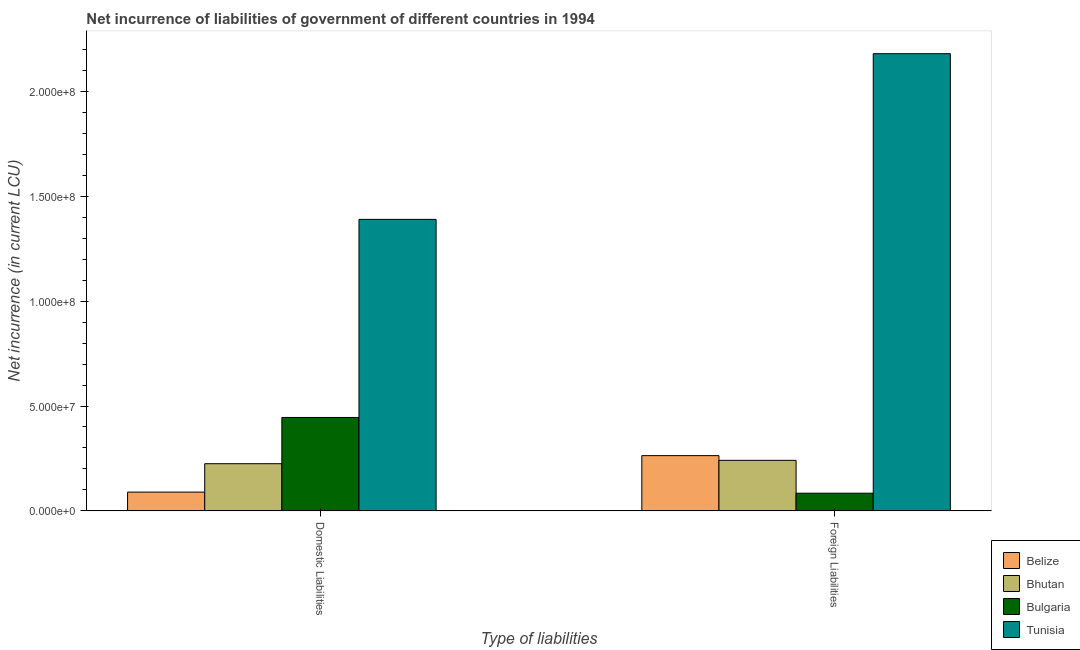How many different coloured bars are there?
Your answer should be very brief. 4. How many bars are there on the 2nd tick from the left?
Your answer should be very brief. 4. What is the label of the 1st group of bars from the left?
Offer a very short reply. Domestic Liabilities. What is the net incurrence of domestic liabilities in Belize?
Provide a succinct answer. 8.96e+06. Across all countries, what is the maximum net incurrence of foreign liabilities?
Your answer should be very brief. 2.18e+08. Across all countries, what is the minimum net incurrence of domestic liabilities?
Ensure brevity in your answer.  8.96e+06. In which country was the net incurrence of domestic liabilities maximum?
Keep it short and to the point. Tunisia. In which country was the net incurrence of domestic liabilities minimum?
Ensure brevity in your answer.  Belize. What is the total net incurrence of domestic liabilities in the graph?
Give a very brief answer. 2.15e+08. What is the difference between the net incurrence of domestic liabilities in Bhutan and that in Belize?
Keep it short and to the point. 1.35e+07. What is the difference between the net incurrence of foreign liabilities in Tunisia and the net incurrence of domestic liabilities in Bhutan?
Make the answer very short. 1.96e+08. What is the average net incurrence of domestic liabilities per country?
Give a very brief answer. 5.38e+07. What is the difference between the net incurrence of domestic liabilities and net incurrence of foreign liabilities in Bulgaria?
Keep it short and to the point. 3.61e+07. What is the ratio of the net incurrence of domestic liabilities in Tunisia to that in Bhutan?
Offer a very short reply. 6.18. In how many countries, is the net incurrence of domestic liabilities greater than the average net incurrence of domestic liabilities taken over all countries?
Make the answer very short. 1. What does the 1st bar from the left in Foreign Liabilities represents?
Make the answer very short. Belize. Are the values on the major ticks of Y-axis written in scientific E-notation?
Provide a succinct answer. Yes. Where does the legend appear in the graph?
Make the answer very short. Bottom right. What is the title of the graph?
Make the answer very short. Net incurrence of liabilities of government of different countries in 1994. Does "Honduras" appear as one of the legend labels in the graph?
Offer a terse response. No. What is the label or title of the X-axis?
Give a very brief answer. Type of liabilities. What is the label or title of the Y-axis?
Ensure brevity in your answer.  Net incurrence (in current LCU). What is the Net incurrence (in current LCU) in Belize in Domestic Liabilities?
Offer a very short reply. 8.96e+06. What is the Net incurrence (in current LCU) of Bhutan in Domestic Liabilities?
Your answer should be compact. 2.25e+07. What is the Net incurrence (in current LCU) in Bulgaria in Domestic Liabilities?
Your answer should be compact. 4.45e+07. What is the Net incurrence (in current LCU) in Tunisia in Domestic Liabilities?
Provide a succinct answer. 1.39e+08. What is the Net incurrence (in current LCU) of Belize in Foreign Liabilities?
Provide a short and direct response. 2.63e+07. What is the Net incurrence (in current LCU) of Bhutan in Foreign Liabilities?
Your response must be concise. 2.41e+07. What is the Net incurrence (in current LCU) in Bulgaria in Foreign Liabilities?
Provide a succinct answer. 8.43e+06. What is the Net incurrence (in current LCU) of Tunisia in Foreign Liabilities?
Your answer should be very brief. 2.18e+08. Across all Type of liabilities, what is the maximum Net incurrence (in current LCU) in Belize?
Provide a short and direct response. 2.63e+07. Across all Type of liabilities, what is the maximum Net incurrence (in current LCU) of Bhutan?
Your answer should be very brief. 2.41e+07. Across all Type of liabilities, what is the maximum Net incurrence (in current LCU) of Bulgaria?
Keep it short and to the point. 4.45e+07. Across all Type of liabilities, what is the maximum Net incurrence (in current LCU) of Tunisia?
Give a very brief answer. 2.18e+08. Across all Type of liabilities, what is the minimum Net incurrence (in current LCU) of Belize?
Provide a succinct answer. 8.96e+06. Across all Type of liabilities, what is the minimum Net incurrence (in current LCU) of Bhutan?
Provide a succinct answer. 2.25e+07. Across all Type of liabilities, what is the minimum Net incurrence (in current LCU) in Bulgaria?
Give a very brief answer. 8.43e+06. Across all Type of liabilities, what is the minimum Net incurrence (in current LCU) in Tunisia?
Your answer should be compact. 1.39e+08. What is the total Net incurrence (in current LCU) in Belize in the graph?
Make the answer very short. 3.53e+07. What is the total Net incurrence (in current LCU) of Bhutan in the graph?
Give a very brief answer. 4.66e+07. What is the total Net incurrence (in current LCU) in Bulgaria in the graph?
Your answer should be very brief. 5.30e+07. What is the total Net incurrence (in current LCU) of Tunisia in the graph?
Make the answer very short. 3.57e+08. What is the difference between the Net incurrence (in current LCU) in Belize in Domestic Liabilities and that in Foreign Liabilities?
Ensure brevity in your answer.  -1.74e+07. What is the difference between the Net incurrence (in current LCU) in Bhutan in Domestic Liabilities and that in Foreign Liabilities?
Offer a terse response. -1.60e+06. What is the difference between the Net incurrence (in current LCU) of Bulgaria in Domestic Liabilities and that in Foreign Liabilities?
Give a very brief answer. 3.61e+07. What is the difference between the Net incurrence (in current LCU) in Tunisia in Domestic Liabilities and that in Foreign Liabilities?
Ensure brevity in your answer.  -7.90e+07. What is the difference between the Net incurrence (in current LCU) of Belize in Domestic Liabilities and the Net incurrence (in current LCU) of Bhutan in Foreign Liabilities?
Offer a very short reply. -1.51e+07. What is the difference between the Net incurrence (in current LCU) of Belize in Domestic Liabilities and the Net incurrence (in current LCU) of Bulgaria in Foreign Liabilities?
Offer a terse response. 5.23e+05. What is the difference between the Net incurrence (in current LCU) of Belize in Domestic Liabilities and the Net incurrence (in current LCU) of Tunisia in Foreign Liabilities?
Keep it short and to the point. -2.09e+08. What is the difference between the Net incurrence (in current LCU) in Bhutan in Domestic Liabilities and the Net incurrence (in current LCU) in Bulgaria in Foreign Liabilities?
Your response must be concise. 1.41e+07. What is the difference between the Net incurrence (in current LCU) of Bhutan in Domestic Liabilities and the Net incurrence (in current LCU) of Tunisia in Foreign Liabilities?
Give a very brief answer. -1.96e+08. What is the difference between the Net incurrence (in current LCU) of Bulgaria in Domestic Liabilities and the Net incurrence (in current LCU) of Tunisia in Foreign Liabilities?
Offer a very short reply. -1.73e+08. What is the average Net incurrence (in current LCU) in Belize per Type of liabilities?
Your answer should be compact. 1.77e+07. What is the average Net incurrence (in current LCU) in Bhutan per Type of liabilities?
Provide a short and direct response. 2.33e+07. What is the average Net incurrence (in current LCU) of Bulgaria per Type of liabilities?
Your answer should be compact. 2.65e+07. What is the average Net incurrence (in current LCU) of Tunisia per Type of liabilities?
Provide a succinct answer. 1.78e+08. What is the difference between the Net incurrence (in current LCU) in Belize and Net incurrence (in current LCU) in Bhutan in Domestic Liabilities?
Offer a terse response. -1.35e+07. What is the difference between the Net incurrence (in current LCU) of Belize and Net incurrence (in current LCU) of Bulgaria in Domestic Liabilities?
Offer a very short reply. -3.56e+07. What is the difference between the Net incurrence (in current LCU) of Belize and Net incurrence (in current LCU) of Tunisia in Domestic Liabilities?
Your response must be concise. -1.30e+08. What is the difference between the Net incurrence (in current LCU) of Bhutan and Net incurrence (in current LCU) of Bulgaria in Domestic Liabilities?
Give a very brief answer. -2.20e+07. What is the difference between the Net incurrence (in current LCU) in Bhutan and Net incurrence (in current LCU) in Tunisia in Domestic Liabilities?
Your answer should be compact. -1.16e+08. What is the difference between the Net incurrence (in current LCU) of Bulgaria and Net incurrence (in current LCU) of Tunisia in Domestic Liabilities?
Your answer should be very brief. -9.45e+07. What is the difference between the Net incurrence (in current LCU) of Belize and Net incurrence (in current LCU) of Bhutan in Foreign Liabilities?
Your response must be concise. 2.25e+06. What is the difference between the Net incurrence (in current LCU) in Belize and Net incurrence (in current LCU) in Bulgaria in Foreign Liabilities?
Make the answer very short. 1.79e+07. What is the difference between the Net incurrence (in current LCU) of Belize and Net incurrence (in current LCU) of Tunisia in Foreign Liabilities?
Make the answer very short. -1.92e+08. What is the difference between the Net incurrence (in current LCU) of Bhutan and Net incurrence (in current LCU) of Bulgaria in Foreign Liabilities?
Give a very brief answer. 1.57e+07. What is the difference between the Net incurrence (in current LCU) in Bhutan and Net incurrence (in current LCU) in Tunisia in Foreign Liabilities?
Ensure brevity in your answer.  -1.94e+08. What is the difference between the Net incurrence (in current LCU) of Bulgaria and Net incurrence (in current LCU) of Tunisia in Foreign Liabilities?
Make the answer very short. -2.10e+08. What is the ratio of the Net incurrence (in current LCU) of Belize in Domestic Liabilities to that in Foreign Liabilities?
Offer a very short reply. 0.34. What is the ratio of the Net incurrence (in current LCU) in Bhutan in Domestic Liabilities to that in Foreign Liabilities?
Offer a very short reply. 0.93. What is the ratio of the Net incurrence (in current LCU) of Bulgaria in Domestic Liabilities to that in Foreign Liabilities?
Make the answer very short. 5.28. What is the ratio of the Net incurrence (in current LCU) of Tunisia in Domestic Liabilities to that in Foreign Liabilities?
Your answer should be compact. 0.64. What is the difference between the highest and the second highest Net incurrence (in current LCU) of Belize?
Give a very brief answer. 1.74e+07. What is the difference between the highest and the second highest Net incurrence (in current LCU) in Bhutan?
Ensure brevity in your answer.  1.60e+06. What is the difference between the highest and the second highest Net incurrence (in current LCU) in Bulgaria?
Ensure brevity in your answer.  3.61e+07. What is the difference between the highest and the second highest Net incurrence (in current LCU) in Tunisia?
Provide a short and direct response. 7.90e+07. What is the difference between the highest and the lowest Net incurrence (in current LCU) in Belize?
Keep it short and to the point. 1.74e+07. What is the difference between the highest and the lowest Net incurrence (in current LCU) in Bhutan?
Offer a very short reply. 1.60e+06. What is the difference between the highest and the lowest Net incurrence (in current LCU) of Bulgaria?
Offer a very short reply. 3.61e+07. What is the difference between the highest and the lowest Net incurrence (in current LCU) of Tunisia?
Give a very brief answer. 7.90e+07. 